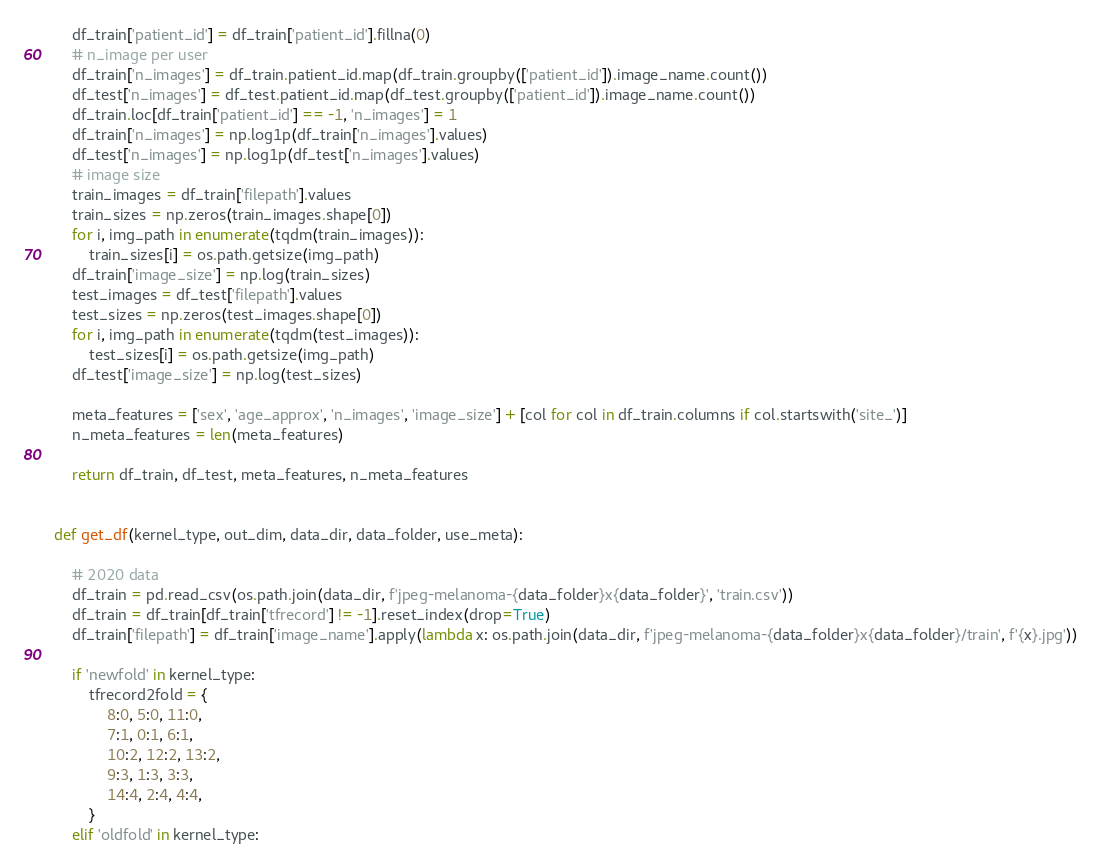Convert code to text. <code><loc_0><loc_0><loc_500><loc_500><_Python_>    df_train['patient_id'] = df_train['patient_id'].fillna(0)
    # n_image per user
    df_train['n_images'] = df_train.patient_id.map(df_train.groupby(['patient_id']).image_name.count())
    df_test['n_images'] = df_test.patient_id.map(df_test.groupby(['patient_id']).image_name.count())
    df_train.loc[df_train['patient_id'] == -1, 'n_images'] = 1
    df_train['n_images'] = np.log1p(df_train['n_images'].values)
    df_test['n_images'] = np.log1p(df_test['n_images'].values)
    # image size
    train_images = df_train['filepath'].values
    train_sizes = np.zeros(train_images.shape[0])
    for i, img_path in enumerate(tqdm(train_images)):
        train_sizes[i] = os.path.getsize(img_path)
    df_train['image_size'] = np.log(train_sizes)
    test_images = df_test['filepath'].values
    test_sizes = np.zeros(test_images.shape[0])
    for i, img_path in enumerate(tqdm(test_images)):
        test_sizes[i] = os.path.getsize(img_path)
    df_test['image_size'] = np.log(test_sizes)

    meta_features = ['sex', 'age_approx', 'n_images', 'image_size'] + [col for col in df_train.columns if col.startswith('site_')]
    n_meta_features = len(meta_features)

    return df_train, df_test, meta_features, n_meta_features


def get_df(kernel_type, out_dim, data_dir, data_folder, use_meta):

    # 2020 data
    df_train = pd.read_csv(os.path.join(data_dir, f'jpeg-melanoma-{data_folder}x{data_folder}', 'train.csv'))
    df_train = df_train[df_train['tfrecord'] != -1].reset_index(drop=True)
    df_train['filepath'] = df_train['image_name'].apply(lambda x: os.path.join(data_dir, f'jpeg-melanoma-{data_folder}x{data_folder}/train', f'{x}.jpg'))

    if 'newfold' in kernel_type:
        tfrecord2fold = {
            8:0, 5:0, 11:0,
            7:1, 0:1, 6:1,
            10:2, 12:2, 13:2,
            9:3, 1:3, 3:3,
            14:4, 2:4, 4:4,
        }
    elif 'oldfold' in kernel_type:</code> 